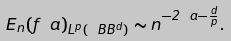<formula> <loc_0><loc_0><loc_500><loc_500>E _ { n } ( f _ { \ } a ) _ { L ^ { p } ( \ B B ^ { d } ) } \sim n ^ { - 2 \ a - \frac { d } { p } } .</formula> 